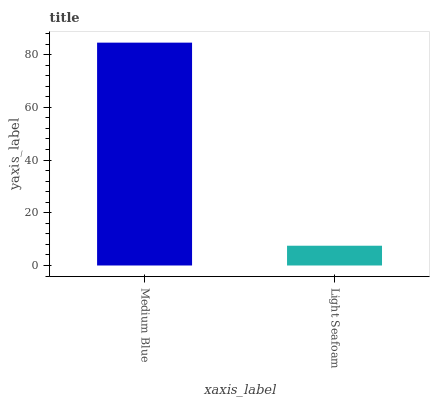Is Light Seafoam the minimum?
Answer yes or no. Yes. Is Medium Blue the maximum?
Answer yes or no. Yes. Is Light Seafoam the maximum?
Answer yes or no. No. Is Medium Blue greater than Light Seafoam?
Answer yes or no. Yes. Is Light Seafoam less than Medium Blue?
Answer yes or no. Yes. Is Light Seafoam greater than Medium Blue?
Answer yes or no. No. Is Medium Blue less than Light Seafoam?
Answer yes or no. No. Is Medium Blue the high median?
Answer yes or no. Yes. Is Light Seafoam the low median?
Answer yes or no. Yes. Is Light Seafoam the high median?
Answer yes or no. No. Is Medium Blue the low median?
Answer yes or no. No. 